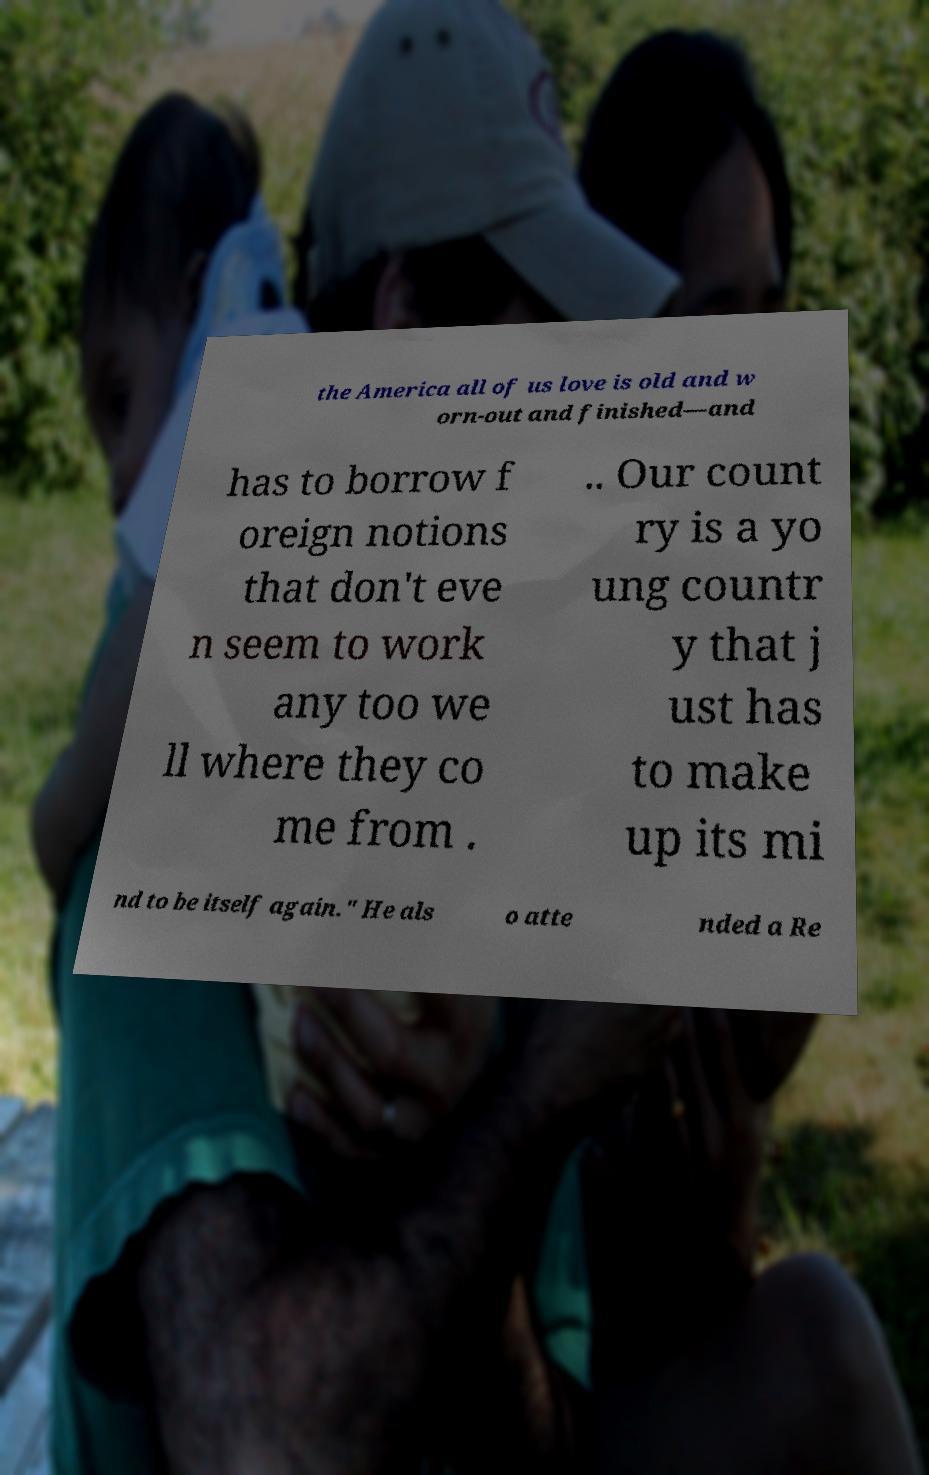Could you extract and type out the text from this image? the America all of us love is old and w orn-out and finished—and has to borrow f oreign notions that don't eve n seem to work any too we ll where they co me from . .. Our count ry is a yo ung countr y that j ust has to make up its mi nd to be itself again." He als o atte nded a Re 